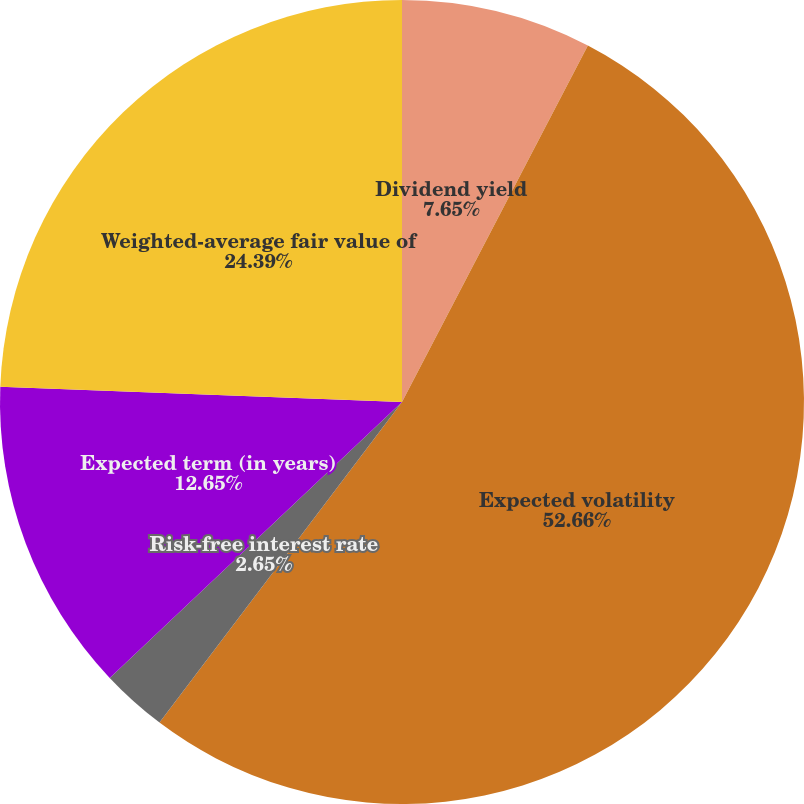<chart> <loc_0><loc_0><loc_500><loc_500><pie_chart><fcel>Dividend yield<fcel>Expected volatility<fcel>Risk-free interest rate<fcel>Expected term (in years)<fcel>Weighted-average fair value of<nl><fcel>7.65%<fcel>52.65%<fcel>2.65%<fcel>12.65%<fcel>24.39%<nl></chart> 